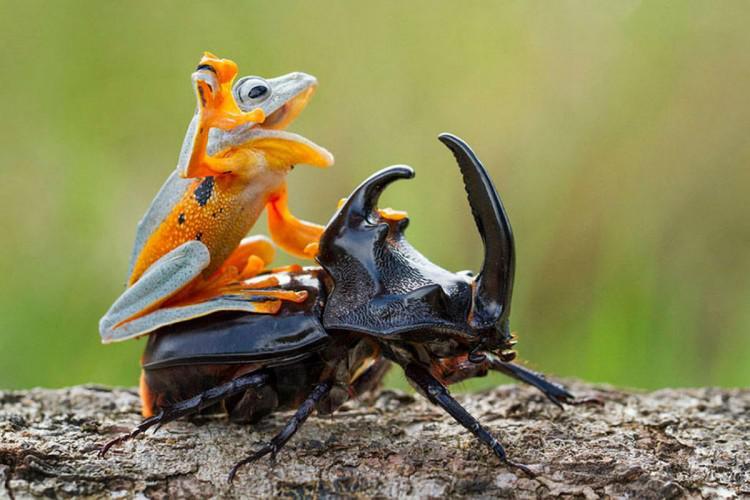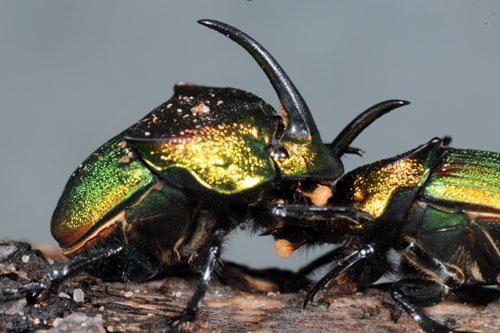The first image is the image on the left, the second image is the image on the right. Given the left and right images, does the statement "At least one image shows a beetle with a large horn." hold true? Answer yes or no. Yes. 